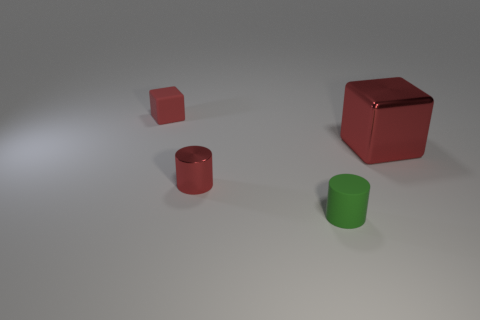Are there fewer large gray blocks than cubes?
Offer a very short reply. Yes. How many other objects are the same color as the rubber cylinder?
Your answer should be very brief. 0. Do the red block to the right of the green matte cylinder and the tiny green object have the same material?
Make the answer very short. No. What is the small red thing that is on the right side of the red rubber thing made of?
Your answer should be very brief. Metal. There is a red metallic thing that is behind the red metallic thing that is on the left side of the green object; what is its size?
Your answer should be compact. Large. Is there a cylinder that has the same material as the big thing?
Provide a succinct answer. Yes. There is a red object that is behind the cube that is right of the small rubber thing left of the small green rubber object; what is its shape?
Make the answer very short. Cube. Does the small matte object that is behind the big thing have the same color as the tiny matte thing that is in front of the large red metal cube?
Provide a short and direct response. No. Is there anything else that is the same size as the red metallic cube?
Provide a short and direct response. No. There is a green matte cylinder; are there any small objects on the left side of it?
Your answer should be compact. Yes. 